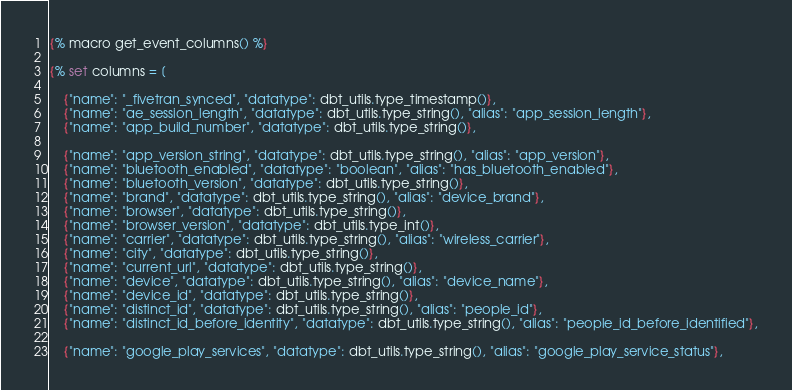<code> <loc_0><loc_0><loc_500><loc_500><_SQL_>{% macro get_event_columns() %}

{% set columns = [

    {"name": "_fivetran_synced", "datatype": dbt_utils.type_timestamp()},
    {"name": "ae_session_length", "datatype": dbt_utils.type_string(), "alias": "app_session_length"},
    {"name": "app_build_number", "datatype": dbt_utils.type_string()},

    {"name": "app_version_string", "datatype": dbt_utils.type_string(), "alias": "app_version"},
    {"name": "bluetooth_enabled", "datatype": "boolean", "alias": "has_bluetooth_enabled"},
    {"name": "bluetooth_version", "datatype": dbt_utils.type_string()},
    {"name": "brand", "datatype": dbt_utils.type_string(), "alias": "device_brand"},
    {"name": "browser", "datatype": dbt_utils.type_string()},
    {"name": "browser_version", "datatype": dbt_utils.type_int()},
    {"name": "carrier", "datatype": dbt_utils.type_string(), "alias": "wireless_carrier"},
    {"name": "city", "datatype": dbt_utils.type_string()},
    {"name": "current_url", "datatype": dbt_utils.type_string()},
    {"name": "device", "datatype": dbt_utils.type_string(), "alias": "device_name"},
    {"name": "device_id", "datatype": dbt_utils.type_string()},
    {"name": "distinct_id", "datatype": dbt_utils.type_string(), "alias": "people_id"},
    {"name": "distinct_id_before_identity", "datatype": dbt_utils.type_string(), "alias": "people_id_before_identified"},

    {"name": "google_play_services", "datatype": dbt_utils.type_string(), "alias": "google_play_service_status"},
</code> 